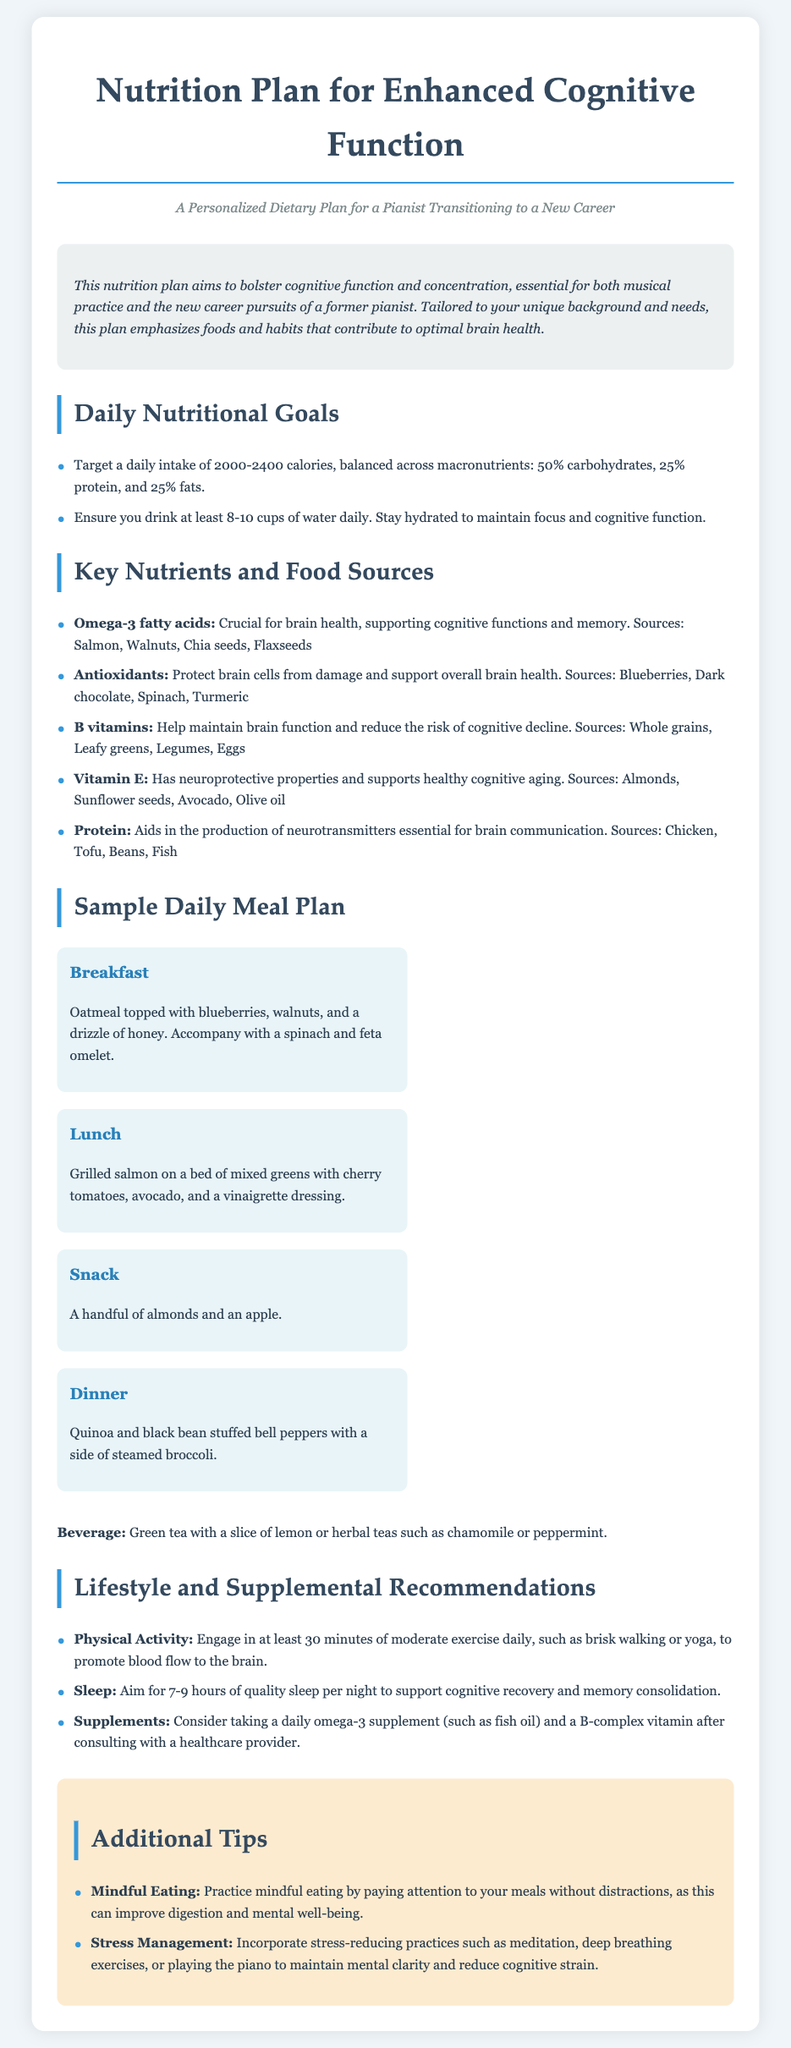What is the daily calorie target range? The document specifies a target daily intake of calories, which is between 2000-2400 calories.
Answer: 2000-2400 calories What is the main focus of this nutrition plan? The introduction states that the main focus is on enhancing cognitive function and concentration for both musical practice and new career pursuits.
Answer: Enhancing cognitive function Which omega-3 sources are mentioned? The document lists foods that are high in omega-3 fatty acids, specifically salmon, walnuts, chia seeds, and flaxseeds.
Answer: Salmon, walnuts, chia seeds, flaxseeds How many hours of sleep should you aim for? According to the lifestyle recommendations, the goal is to aim for 7-9 hours of quality sleep each night to support cognitive recovery.
Answer: 7-9 hours What is one recommended afternoon snack? The document suggests a handful of almonds and an apple as a snack option in the sample daily meal plan.
Answer: Almonds and apple What daily water intake is suggested? The recommendations indicate that you should drink at least 8-10 cups of water daily to maintain hydration.
Answer: 8-10 cups What type of exercise should be engaged in daily? The plan advises at least 30 minutes of moderate exercise daily, which may include brisk walking or yoga.
Answer: Moderate exercise What practice is suggested for stress management? The document mentions incorporating meditation, deep breathing exercises, or playing the piano as a way to manage stress.
Answer: Meditation or deep breathing exercises What is included in the sample breakfast? The sample breakfast consists of oatmeal topped with blueberries, walnuts, and a spinach and feta omelet.
Answer: Oatmeal with blueberries and a spinach omelet 